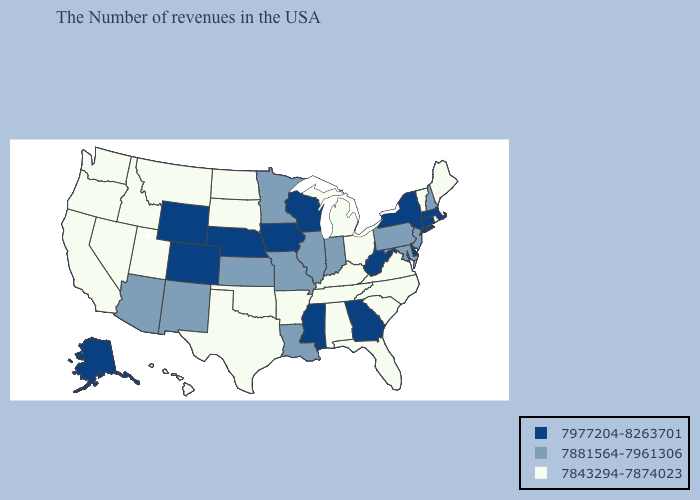Name the states that have a value in the range 7977204-8263701?
Give a very brief answer. Massachusetts, Connecticut, New York, Delaware, West Virginia, Georgia, Wisconsin, Mississippi, Iowa, Nebraska, Wyoming, Colorado, Alaska. Name the states that have a value in the range 7977204-8263701?
Be succinct. Massachusetts, Connecticut, New York, Delaware, West Virginia, Georgia, Wisconsin, Mississippi, Iowa, Nebraska, Wyoming, Colorado, Alaska. What is the highest value in the USA?
Give a very brief answer. 7977204-8263701. What is the lowest value in the USA?
Concise answer only. 7843294-7874023. What is the lowest value in the Northeast?
Give a very brief answer. 7843294-7874023. Does the first symbol in the legend represent the smallest category?
Concise answer only. No. Does New York have a higher value than Connecticut?
Concise answer only. No. Name the states that have a value in the range 7881564-7961306?
Quick response, please. New Hampshire, New Jersey, Maryland, Pennsylvania, Indiana, Illinois, Louisiana, Missouri, Minnesota, Kansas, New Mexico, Arizona. Is the legend a continuous bar?
Keep it brief. No. Among the states that border Arkansas , which have the lowest value?
Quick response, please. Tennessee, Oklahoma, Texas. Name the states that have a value in the range 7977204-8263701?
Answer briefly. Massachusetts, Connecticut, New York, Delaware, West Virginia, Georgia, Wisconsin, Mississippi, Iowa, Nebraska, Wyoming, Colorado, Alaska. What is the value of Georgia?
Short answer required. 7977204-8263701. Does Illinois have the highest value in the USA?
Be succinct. No. Name the states that have a value in the range 7881564-7961306?
Quick response, please. New Hampshire, New Jersey, Maryland, Pennsylvania, Indiana, Illinois, Louisiana, Missouri, Minnesota, Kansas, New Mexico, Arizona. 